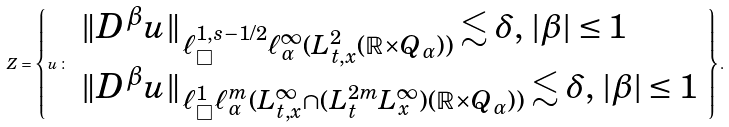<formula> <loc_0><loc_0><loc_500><loc_500>Z = \left \{ u \, \colon \, \begin{array} { l } \| D ^ { \beta } u \| _ { \ell ^ { 1 , s - 1 / 2 } _ { \Box } \ell ^ { \infty } _ { \alpha } ( L ^ { 2 } _ { t , x } ( \mathbb { R } \times Q _ { \alpha } ) ) } \lesssim \delta , \, | \beta | \leq 1 \\ \| D ^ { \beta } u \| _ { \ell ^ { 1 } _ { \Box } \ell ^ { m } _ { \alpha } ( L ^ { \infty } _ { t , x } \cap ( L ^ { 2 m } _ { t } L ^ { \infty } _ { x } ) ( \mathbb { R } \times Q _ { \alpha } ) ) } \lesssim \delta , \, | \beta | \leq 1 \end{array} \right \} .</formula> 